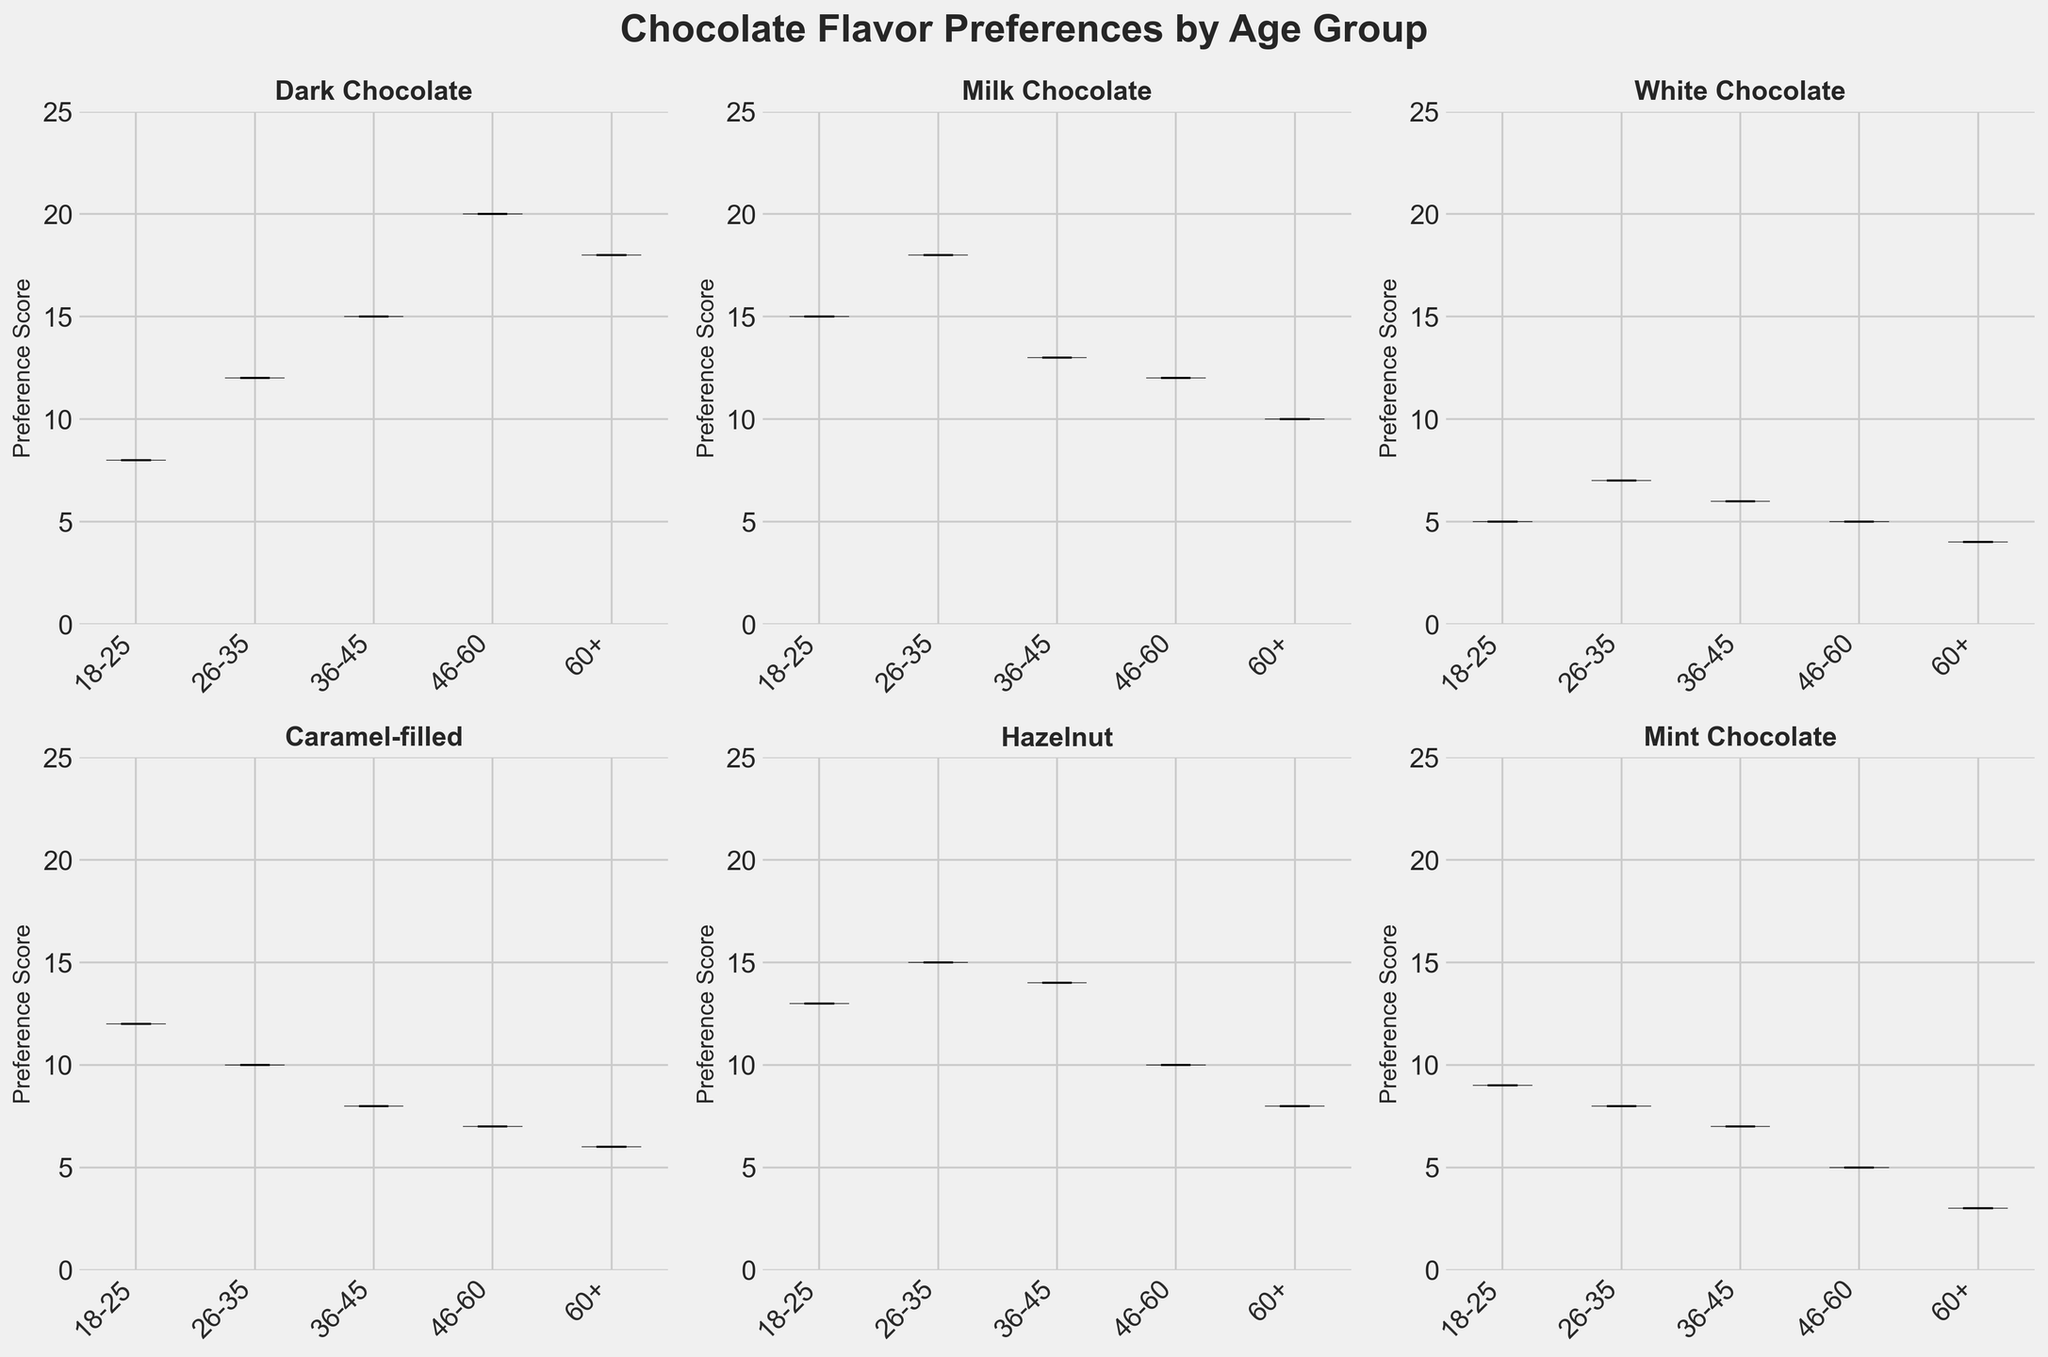what is the title of the subplot figure? The title is located at the top center of the figure and summarizes the content of the plot.
Answer: Chocolate Flavor Preferences by Age Group Which flavor has the highest median preference among the 18-25 age group? The median values are indicated by the line within each violin plot. For the 18-25 age group, the highest median can be found by comparing these lines. The highest median line is for Milk Chocolate
Answer: Milk Chocolate Which age group shows the lowest median preference for Mint Chocolate? Compare the median lines (the horizontal lines within the violins) for Mint Chocolate across all age groups. The 60+ age group shows the lowest median line.
Answer: 60+ Which age group prefers Hazelnut the most? Look at the median lines of Hazelnut across different age groups. The group with the highest median line indicates the highest preference, which is 36-45 age group.
Answer: 36-45 Is Dark Chocolate more popular among younger or older age groups? Compare the median and spread of Dark Chocolate preference plots. Older age groups (46-60 and 60+) have higher medians than younger ones (18-25).
Answer: Older age groups How does the preference for Caramel-filled chocolates change with age? Examine the median lines and shape for Caramel-filled chocolates among different age groups. Preference generally decreases as age increases
Answer: Decreases Which age group shows the most variance in their preference for Milk Chocolate? The variance can be inferred from the width and spread of the violin plots. The 18-25 age group has the widest spread for Milk Chocolate
Answer: 18-25 For which flavor do the age groups have the least variation in preference? The least variation is indicated by the narrowest violins. Mint Chocolate shows the least variation across all age groups.
Answer: Mint Chocolate Which flavor shows a distinctive shift in preference as age increases? Look at how the medians and distributions shift across age groups. Dark Chocolate shows a clear increase in preference with age.
Answer: Dark Chocolate 